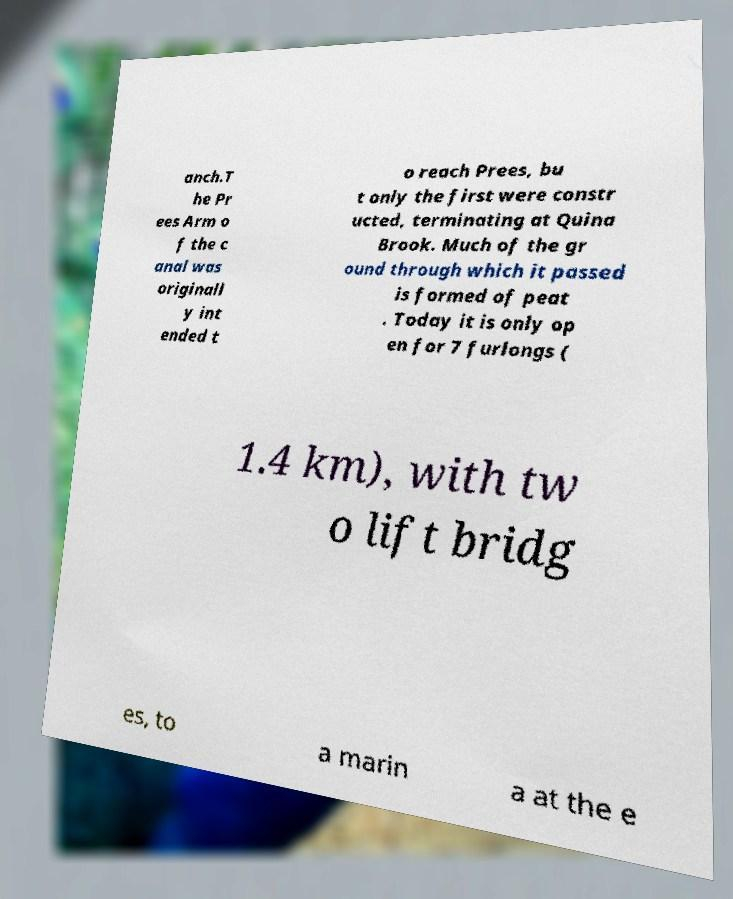Could you assist in decoding the text presented in this image and type it out clearly? anch.T he Pr ees Arm o f the c anal was originall y int ended t o reach Prees, bu t only the first were constr ucted, terminating at Quina Brook. Much of the gr ound through which it passed is formed of peat . Today it is only op en for 7 furlongs ( 1.4 km), with tw o lift bridg es, to a marin a at the e 